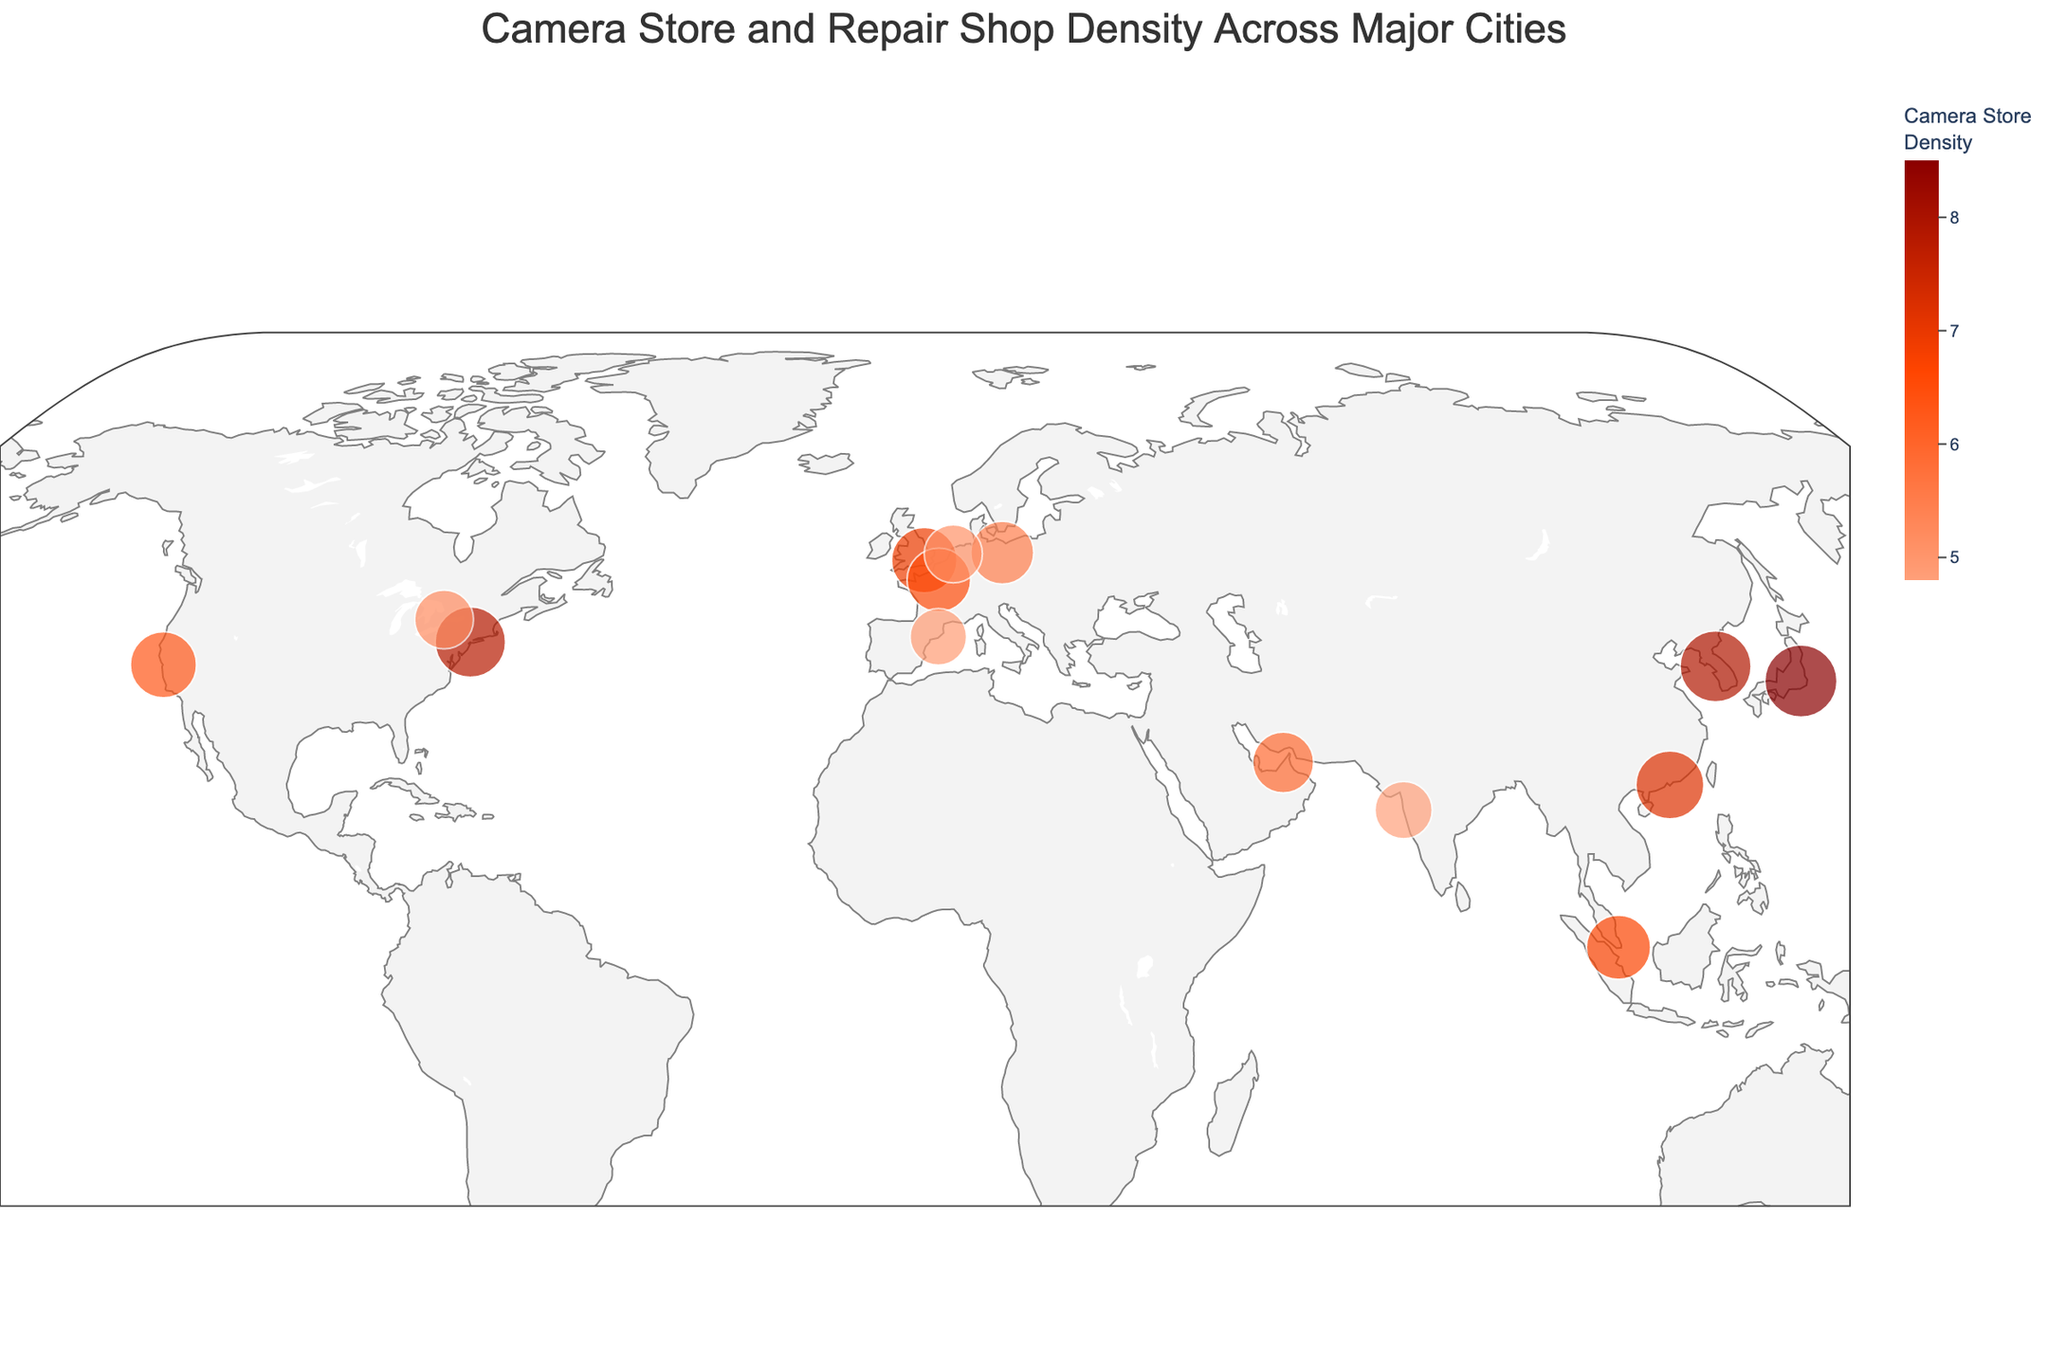What's the title of the figure? The title is usually at the top of the figure to provide context about the data being visualized. Here the title "Camera Store and Repair Shop Density Across Major Cities" is given at the top.
Answer: Camera Store and Repair Shop Density Across Major Cities How many cities are included in the plot? Each city corresponds to a data point on the plot. By counting the data entries, we can determine the total number of cities included.
Answer: 15 Which city has the highest camera store density? Look for the data point with the darkest color on the plot, which corresponds to the highest density value according to the color scale.
Answer: Tokyo What is the camera store density in Amsterdam? Hover over or examine the data point corresponding to Amsterdam to find the camera store density value.
Answer: 5.1 Compare the repair shop density of New York City and Tokyo. Which one has a higher density? Check the sizes of the data points for New York City and Tokyo, as larger sizes indicate higher repair shop density. Tokyo's point is bigger than New York City's.
Answer: Tokyo What is the difference in camera store density between Sydney and Singapore? Locate the data points for Sydney and Singapore, note their camera store densities, and calculate the difference: 6.7 (Singapore) - 5.8 (Sydney).
Answer: 0.9 Identify the city with the lowest repair shop density. Look for the smallest data point on the plot, as the size of the point reflects the repair shop density.
Answer: Mumbai Where is the center of the map projection approximately? The map center is where the focus of the plot appears to be, located geographically. The plot center is around 30° latitude and 0° longitude.
Answer: Around 30° latitude, 0° longitude Which region shows a higher concentration of camera-related services, Asia or Europe? Compare the density values of Asian cities (Tokyo, Hong Kong, Singapore, Seoul, Mumbai) with those in Europe (London, Paris, Berlin, Amsterdam, Barcelona). Asia has higher density figures.
Answer: Asia What is the average repair shop density across all cities shown? Sum all repair shop densities and divide by the number of cities: (6.2 + 5.9 + 5.1 + 4.8 + 5.5 + 4.9 + 4.3 + 4.7 + 5.2 + 6.0 + 4.1 + 3.9 + 4.4 + 4.0 + 3.8) / 15 = 4.9
Answer: 4.9 